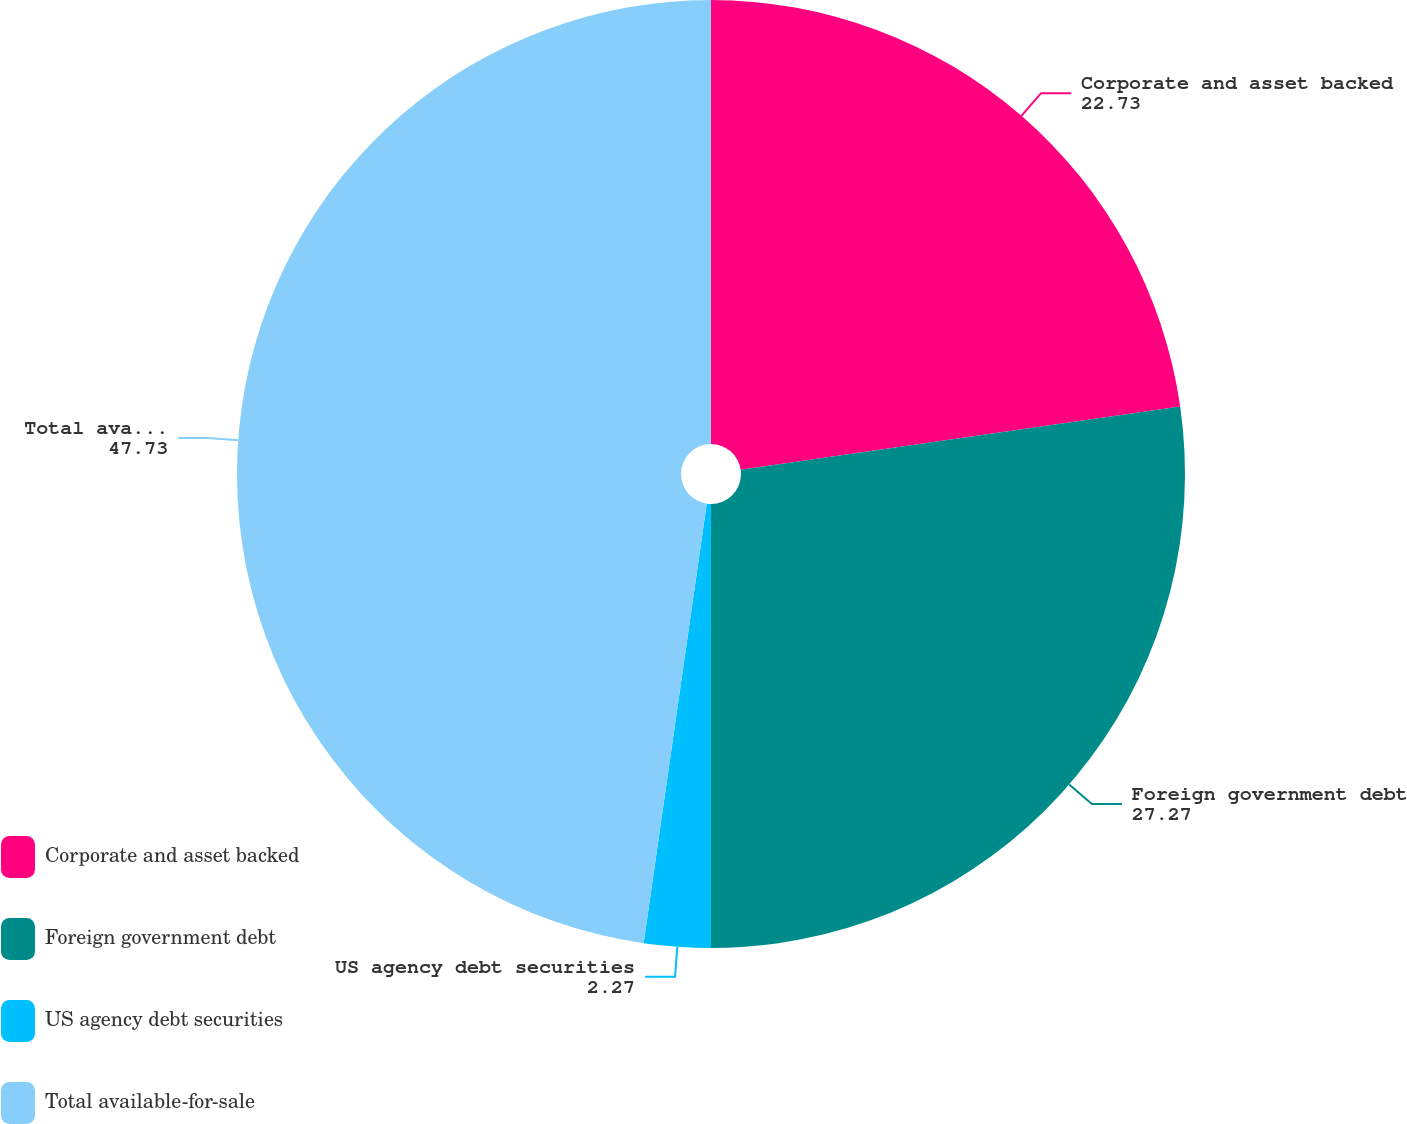Convert chart to OTSL. <chart><loc_0><loc_0><loc_500><loc_500><pie_chart><fcel>Corporate and asset backed<fcel>Foreign government debt<fcel>US agency debt securities<fcel>Total available-for-sale<nl><fcel>22.73%<fcel>27.27%<fcel>2.27%<fcel>47.73%<nl></chart> 